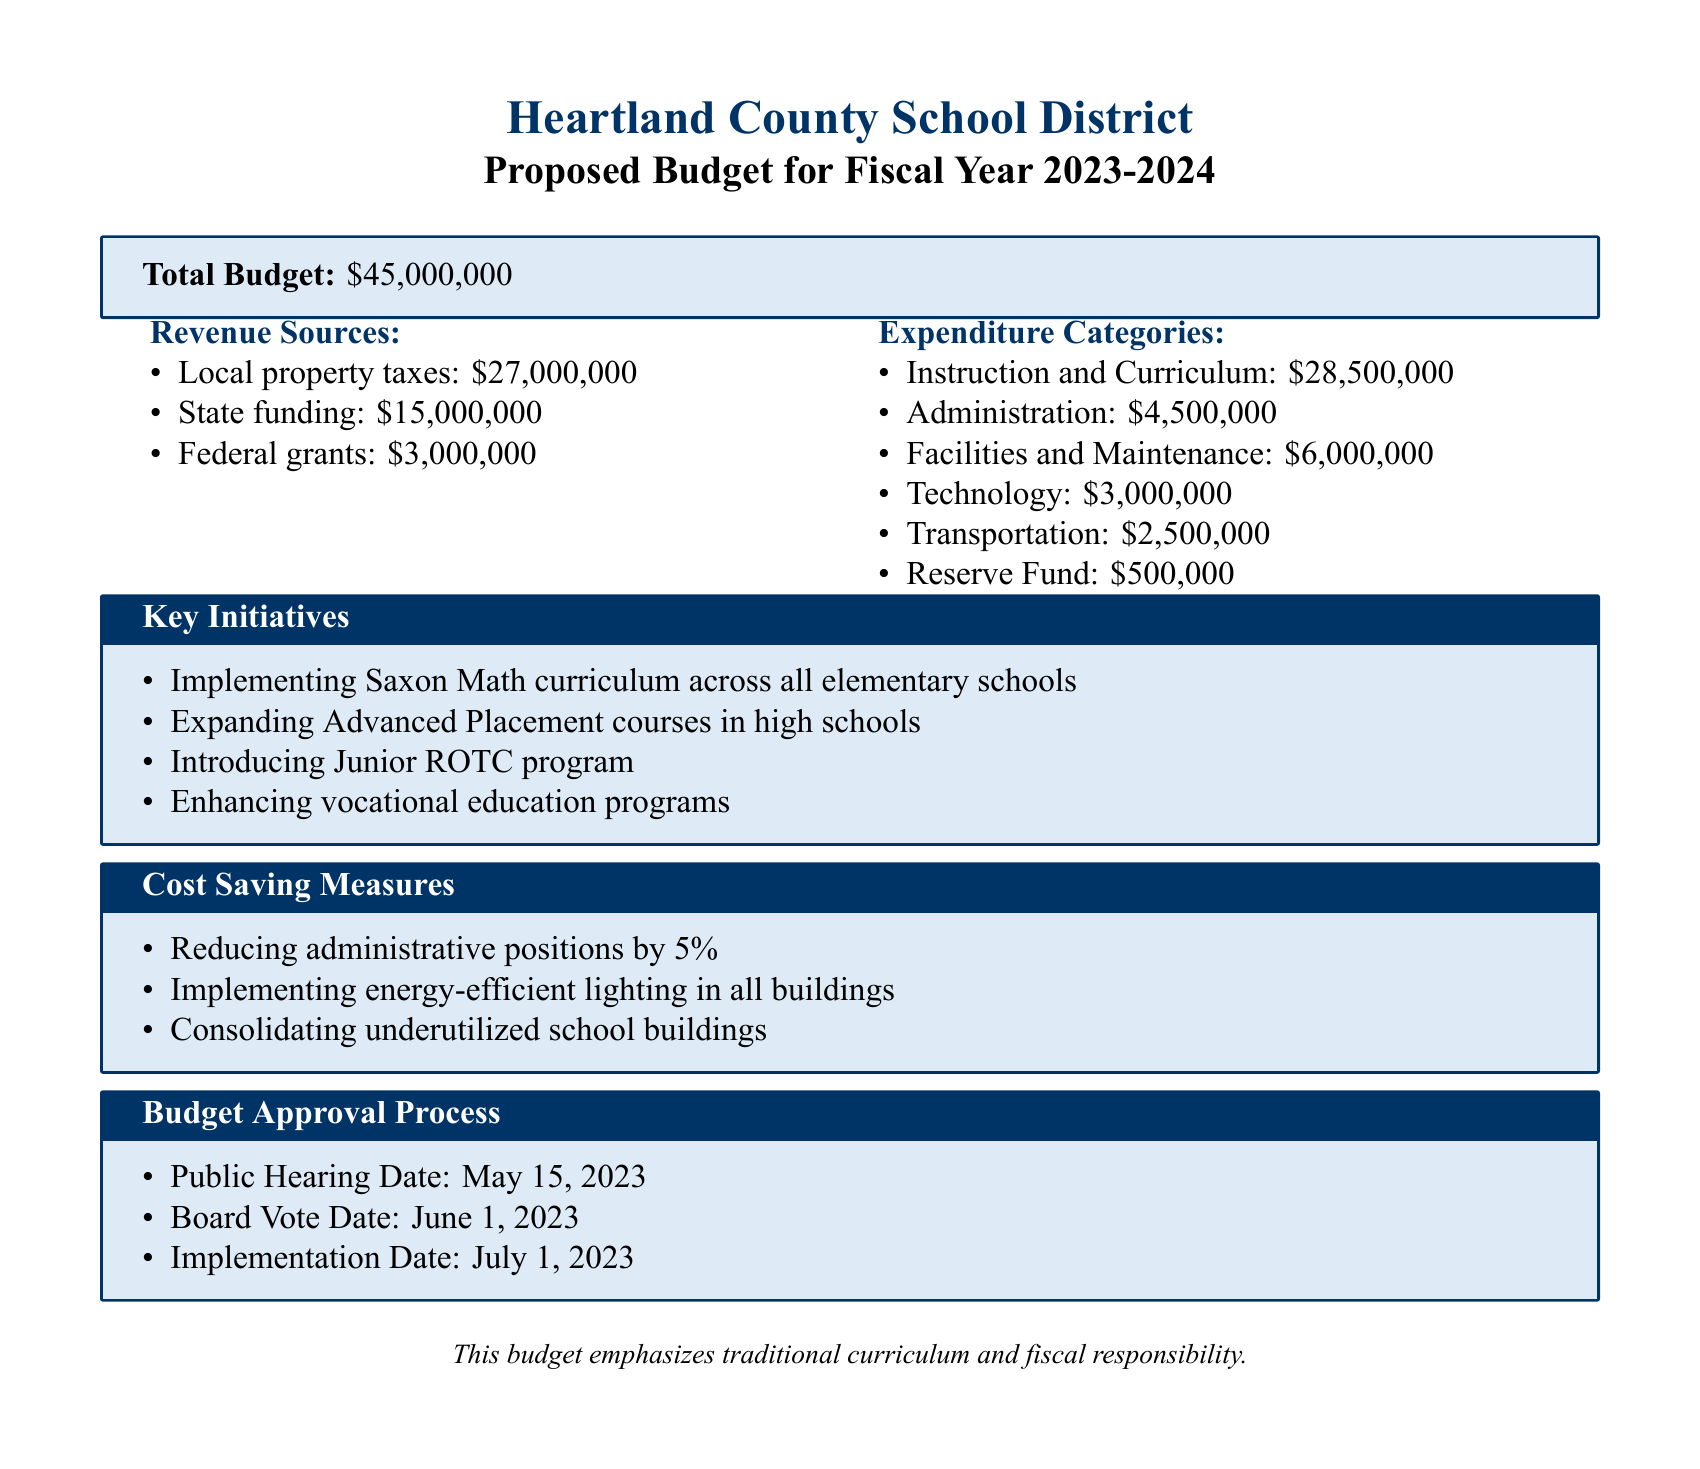What is the total budget? The total budget is explicitly stated in the document.
Answer: $45,000,000 What are the local property taxes? Local property taxes are one of the revenue sources listed in the document.
Answer: $27,000,000 When is the public hearing date? The public hearing date is mentioned in the budget approval process section.
Answer: May 15, 2023 What percentage of administrative positions will be reduced? The cost-saving measure regarding administrative positions includes a specific percentage.
Answer: 5% What curriculum is being implemented in elementary schools? The key initiatives section specifically names the curriculum being implemented.
Answer: Saxon Math How much is allocated for transportation? The expenditure categories include a specific amount allocated for transportation.
Answer: $2,500,000 What initiative is introduced alongside vocational education? The key initiatives mention a program introduced that complements vocational education.
Answer: Junior ROTC program What is the reserve fund amount? The reserve fund is listed in the expenditure categories and specifies the amount.
Answer: $500,000 What is the implementation date of the budget? The implementation date is outlined in the budget approval process.
Answer: July 1, 2023 